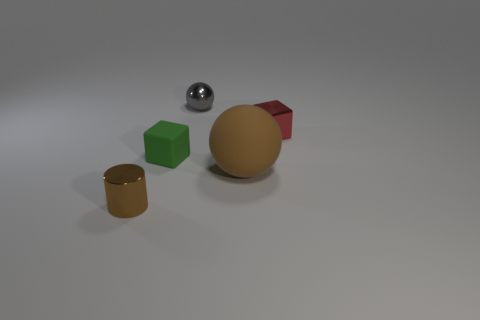How many green objects are there?
Keep it short and to the point. 1. What number of large cyan balls have the same material as the cylinder?
Offer a very short reply. 0. What number of objects are metallic objects that are behind the brown shiny cylinder or green objects?
Make the answer very short. 3. Is the number of tiny green things that are on the left side of the small brown object less than the number of red objects on the left side of the red metal thing?
Offer a very short reply. No. Are there any large rubber spheres to the right of the red metallic object?
Provide a short and direct response. No. How many things are brown objects that are behind the cylinder or brown objects that are behind the brown metallic object?
Your answer should be compact. 1. How many big rubber blocks have the same color as the matte sphere?
Ensure brevity in your answer.  0. There is a tiny shiny object that is the same shape as the large object; what color is it?
Offer a terse response. Gray. What is the shape of the metal thing that is in front of the tiny gray sphere and on the right side of the brown shiny cylinder?
Your answer should be compact. Cube. Is the number of tiny metal cylinders greater than the number of large cyan shiny cylinders?
Ensure brevity in your answer.  Yes. 